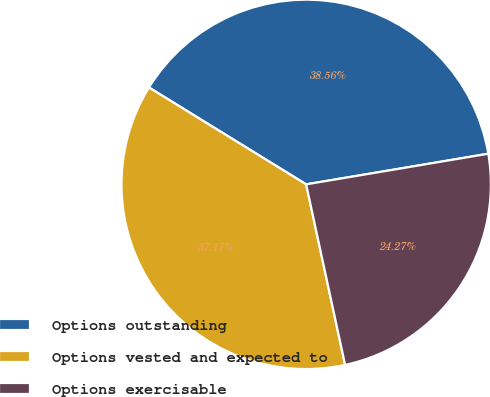<chart> <loc_0><loc_0><loc_500><loc_500><pie_chart><fcel>Options outstanding<fcel>Options vested and expected to<fcel>Options exercisable<nl><fcel>38.56%<fcel>37.17%<fcel>24.27%<nl></chart> 